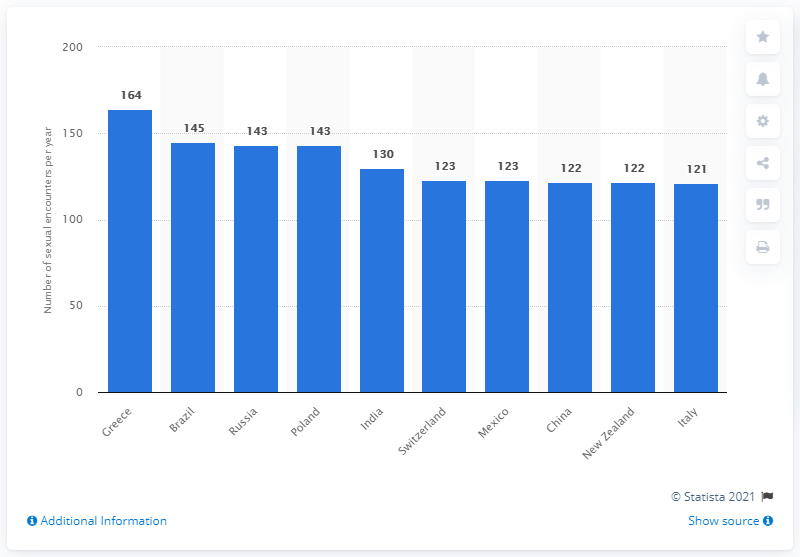Mention a couple of crucial points in this snapshot. According to a recent study, Greece has the highest number of sexual encounters per person per year among all countries in the world. In a year, people in India on average reported having 130 sexual encounters. The total number of sexual encounters between China and Mexico is 245. 